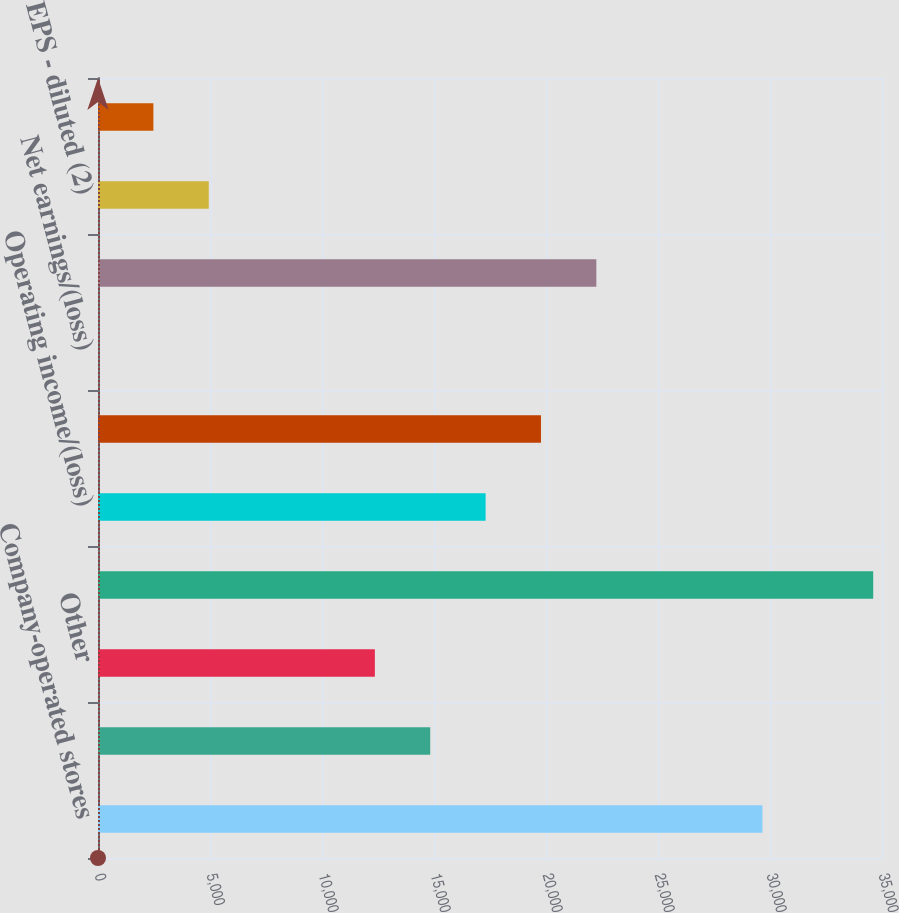<chart> <loc_0><loc_0><loc_500><loc_500><bar_chart><fcel>Company-operated stores<fcel>Licensed stores<fcel>Other<fcel>Total net revenues<fcel>Operating income/(loss)<fcel>Net earnings including<fcel>Net earnings/(loss)<fcel>Net earnings attributable to<fcel>EPS - diluted (2)<fcel>Cash dividends declared per<nl><fcel>29663.3<fcel>14831.8<fcel>12359.9<fcel>34607.2<fcel>17303.7<fcel>19775.7<fcel>0.3<fcel>22247.6<fcel>4944.14<fcel>2472.22<nl></chart> 